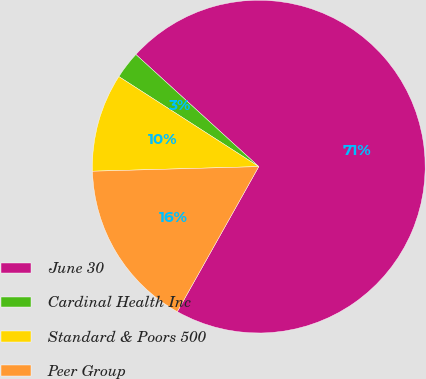Convert chart to OTSL. <chart><loc_0><loc_0><loc_500><loc_500><pie_chart><fcel>June 30<fcel>Cardinal Health Inc<fcel>Standard & Poors 500<fcel>Peer Group<nl><fcel>71.37%<fcel>2.67%<fcel>9.54%<fcel>16.41%<nl></chart> 